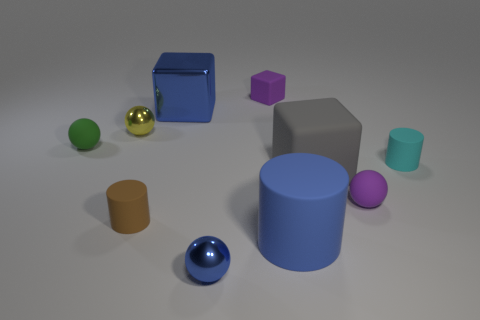Subtract all tiny cylinders. How many cylinders are left? 1 Subtract 3 cubes. How many cubes are left? 0 Subtract all cyan cylinders. How many cylinders are left? 2 Subtract all gray blocks. How many brown cylinders are left? 1 Subtract all tiny cubes. Subtract all small matte balls. How many objects are left? 7 Add 9 small blue metal things. How many small blue metal things are left? 10 Add 7 big balls. How many big balls exist? 7 Subtract 1 purple spheres. How many objects are left? 9 Subtract all blocks. How many objects are left? 7 Subtract all green cylinders. Subtract all gray cubes. How many cylinders are left? 3 